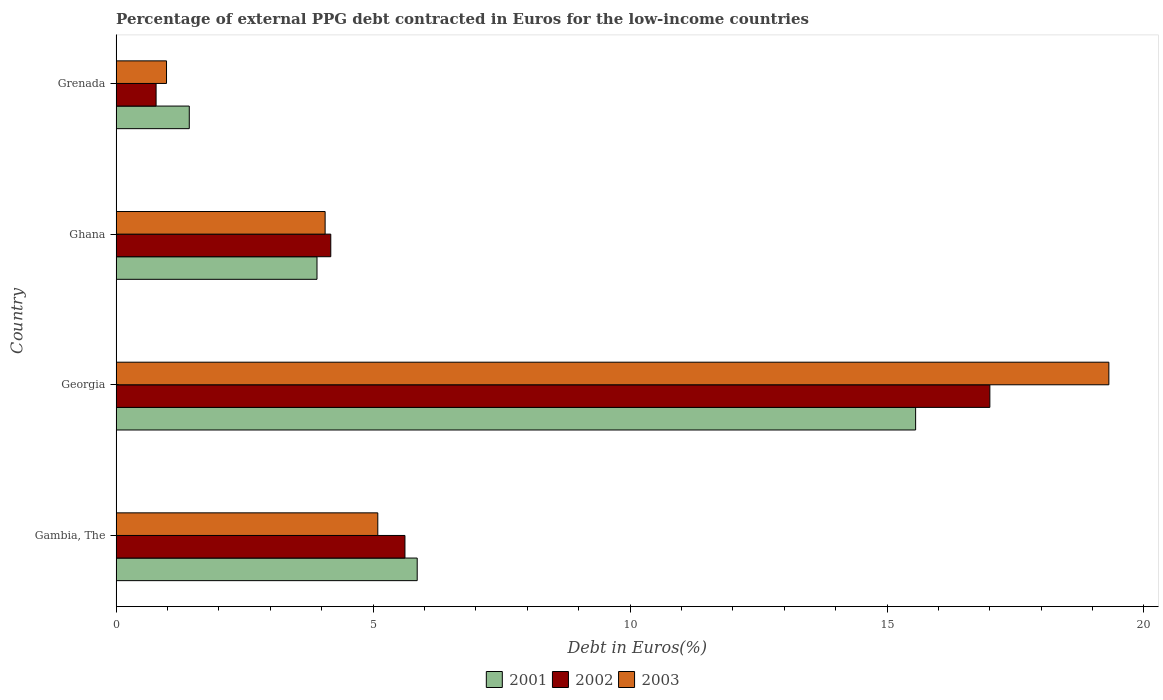How many different coloured bars are there?
Provide a short and direct response. 3. What is the percentage of external PPG debt contracted in Euros in 2001 in Georgia?
Ensure brevity in your answer.  15.56. Across all countries, what is the maximum percentage of external PPG debt contracted in Euros in 2001?
Make the answer very short. 15.56. Across all countries, what is the minimum percentage of external PPG debt contracted in Euros in 2002?
Your response must be concise. 0.78. In which country was the percentage of external PPG debt contracted in Euros in 2002 maximum?
Give a very brief answer. Georgia. In which country was the percentage of external PPG debt contracted in Euros in 2003 minimum?
Offer a terse response. Grenada. What is the total percentage of external PPG debt contracted in Euros in 2003 in the graph?
Your answer should be compact. 29.45. What is the difference between the percentage of external PPG debt contracted in Euros in 2003 in Georgia and that in Grenada?
Offer a terse response. 18.34. What is the difference between the percentage of external PPG debt contracted in Euros in 2003 in Gambia, The and the percentage of external PPG debt contracted in Euros in 2002 in Georgia?
Make the answer very short. -11.91. What is the average percentage of external PPG debt contracted in Euros in 2003 per country?
Your response must be concise. 7.36. What is the difference between the percentage of external PPG debt contracted in Euros in 2002 and percentage of external PPG debt contracted in Euros in 2001 in Gambia, The?
Your response must be concise. -0.24. What is the ratio of the percentage of external PPG debt contracted in Euros in 2002 in Georgia to that in Grenada?
Give a very brief answer. 21.87. What is the difference between the highest and the second highest percentage of external PPG debt contracted in Euros in 2002?
Ensure brevity in your answer.  11.38. What is the difference between the highest and the lowest percentage of external PPG debt contracted in Euros in 2001?
Provide a short and direct response. 14.13. In how many countries, is the percentage of external PPG debt contracted in Euros in 2001 greater than the average percentage of external PPG debt contracted in Euros in 2001 taken over all countries?
Give a very brief answer. 1. What does the 2nd bar from the bottom in Gambia, The represents?
Provide a short and direct response. 2002. How many bars are there?
Ensure brevity in your answer.  12. Are all the bars in the graph horizontal?
Your answer should be very brief. Yes. What is the difference between two consecutive major ticks on the X-axis?
Offer a very short reply. 5. Are the values on the major ticks of X-axis written in scientific E-notation?
Keep it short and to the point. No. Does the graph contain any zero values?
Offer a terse response. No. Does the graph contain grids?
Your response must be concise. No. Where does the legend appear in the graph?
Provide a succinct answer. Bottom center. How many legend labels are there?
Make the answer very short. 3. How are the legend labels stacked?
Ensure brevity in your answer.  Horizontal. What is the title of the graph?
Your answer should be very brief. Percentage of external PPG debt contracted in Euros for the low-income countries. What is the label or title of the X-axis?
Make the answer very short. Debt in Euros(%). What is the Debt in Euros(%) of 2001 in Gambia, The?
Keep it short and to the point. 5.86. What is the Debt in Euros(%) in 2002 in Gambia, The?
Give a very brief answer. 5.62. What is the Debt in Euros(%) in 2003 in Gambia, The?
Make the answer very short. 5.09. What is the Debt in Euros(%) in 2001 in Georgia?
Offer a very short reply. 15.56. What is the Debt in Euros(%) in 2002 in Georgia?
Offer a very short reply. 17. What is the Debt in Euros(%) in 2003 in Georgia?
Make the answer very short. 19.32. What is the Debt in Euros(%) in 2001 in Ghana?
Provide a short and direct response. 3.91. What is the Debt in Euros(%) in 2002 in Ghana?
Offer a terse response. 4.18. What is the Debt in Euros(%) in 2003 in Ghana?
Keep it short and to the point. 4.07. What is the Debt in Euros(%) in 2001 in Grenada?
Give a very brief answer. 1.42. What is the Debt in Euros(%) of 2002 in Grenada?
Your answer should be compact. 0.78. What is the Debt in Euros(%) of 2003 in Grenada?
Offer a very short reply. 0.98. Across all countries, what is the maximum Debt in Euros(%) in 2001?
Your answer should be compact. 15.56. Across all countries, what is the maximum Debt in Euros(%) in 2002?
Keep it short and to the point. 17. Across all countries, what is the maximum Debt in Euros(%) of 2003?
Offer a terse response. 19.32. Across all countries, what is the minimum Debt in Euros(%) in 2001?
Make the answer very short. 1.42. Across all countries, what is the minimum Debt in Euros(%) of 2002?
Your answer should be very brief. 0.78. Across all countries, what is the minimum Debt in Euros(%) of 2003?
Your answer should be very brief. 0.98. What is the total Debt in Euros(%) of 2001 in the graph?
Offer a terse response. 26.75. What is the total Debt in Euros(%) of 2002 in the graph?
Keep it short and to the point. 27.58. What is the total Debt in Euros(%) in 2003 in the graph?
Your response must be concise. 29.45. What is the difference between the Debt in Euros(%) of 2001 in Gambia, The and that in Georgia?
Make the answer very short. -9.7. What is the difference between the Debt in Euros(%) of 2002 in Gambia, The and that in Georgia?
Keep it short and to the point. -11.38. What is the difference between the Debt in Euros(%) in 2003 in Gambia, The and that in Georgia?
Your answer should be compact. -14.23. What is the difference between the Debt in Euros(%) in 2001 in Gambia, The and that in Ghana?
Offer a very short reply. 1.95. What is the difference between the Debt in Euros(%) of 2002 in Gambia, The and that in Ghana?
Provide a succinct answer. 1.44. What is the difference between the Debt in Euros(%) of 2003 in Gambia, The and that in Ghana?
Offer a very short reply. 1.02. What is the difference between the Debt in Euros(%) in 2001 in Gambia, The and that in Grenada?
Offer a terse response. 4.43. What is the difference between the Debt in Euros(%) in 2002 in Gambia, The and that in Grenada?
Your response must be concise. 4.84. What is the difference between the Debt in Euros(%) in 2003 in Gambia, The and that in Grenada?
Your response must be concise. 4.11. What is the difference between the Debt in Euros(%) in 2001 in Georgia and that in Ghana?
Keep it short and to the point. 11.65. What is the difference between the Debt in Euros(%) in 2002 in Georgia and that in Ghana?
Your response must be concise. 12.82. What is the difference between the Debt in Euros(%) in 2003 in Georgia and that in Ghana?
Provide a short and direct response. 15.25. What is the difference between the Debt in Euros(%) of 2001 in Georgia and that in Grenada?
Provide a short and direct response. 14.13. What is the difference between the Debt in Euros(%) in 2002 in Georgia and that in Grenada?
Your answer should be very brief. 16.22. What is the difference between the Debt in Euros(%) in 2003 in Georgia and that in Grenada?
Ensure brevity in your answer.  18.34. What is the difference between the Debt in Euros(%) of 2001 in Ghana and that in Grenada?
Make the answer very short. 2.48. What is the difference between the Debt in Euros(%) in 2002 in Ghana and that in Grenada?
Offer a very short reply. 3.4. What is the difference between the Debt in Euros(%) of 2003 in Ghana and that in Grenada?
Offer a terse response. 3.09. What is the difference between the Debt in Euros(%) of 2001 in Gambia, The and the Debt in Euros(%) of 2002 in Georgia?
Keep it short and to the point. -11.14. What is the difference between the Debt in Euros(%) of 2001 in Gambia, The and the Debt in Euros(%) of 2003 in Georgia?
Offer a very short reply. -13.46. What is the difference between the Debt in Euros(%) in 2002 in Gambia, The and the Debt in Euros(%) in 2003 in Georgia?
Give a very brief answer. -13.7. What is the difference between the Debt in Euros(%) of 2001 in Gambia, The and the Debt in Euros(%) of 2002 in Ghana?
Your answer should be compact. 1.68. What is the difference between the Debt in Euros(%) in 2001 in Gambia, The and the Debt in Euros(%) in 2003 in Ghana?
Your answer should be very brief. 1.79. What is the difference between the Debt in Euros(%) in 2002 in Gambia, The and the Debt in Euros(%) in 2003 in Ghana?
Offer a terse response. 1.55. What is the difference between the Debt in Euros(%) of 2001 in Gambia, The and the Debt in Euros(%) of 2002 in Grenada?
Make the answer very short. 5.08. What is the difference between the Debt in Euros(%) in 2001 in Gambia, The and the Debt in Euros(%) in 2003 in Grenada?
Offer a terse response. 4.88. What is the difference between the Debt in Euros(%) in 2002 in Gambia, The and the Debt in Euros(%) in 2003 in Grenada?
Keep it short and to the point. 4.64. What is the difference between the Debt in Euros(%) in 2001 in Georgia and the Debt in Euros(%) in 2002 in Ghana?
Make the answer very short. 11.38. What is the difference between the Debt in Euros(%) of 2001 in Georgia and the Debt in Euros(%) of 2003 in Ghana?
Offer a terse response. 11.49. What is the difference between the Debt in Euros(%) in 2002 in Georgia and the Debt in Euros(%) in 2003 in Ghana?
Ensure brevity in your answer.  12.93. What is the difference between the Debt in Euros(%) of 2001 in Georgia and the Debt in Euros(%) of 2002 in Grenada?
Make the answer very short. 14.78. What is the difference between the Debt in Euros(%) in 2001 in Georgia and the Debt in Euros(%) in 2003 in Grenada?
Offer a terse response. 14.58. What is the difference between the Debt in Euros(%) of 2002 in Georgia and the Debt in Euros(%) of 2003 in Grenada?
Offer a terse response. 16.02. What is the difference between the Debt in Euros(%) in 2001 in Ghana and the Debt in Euros(%) in 2002 in Grenada?
Keep it short and to the point. 3.13. What is the difference between the Debt in Euros(%) in 2001 in Ghana and the Debt in Euros(%) in 2003 in Grenada?
Ensure brevity in your answer.  2.93. What is the difference between the Debt in Euros(%) in 2002 in Ghana and the Debt in Euros(%) in 2003 in Grenada?
Your answer should be very brief. 3.2. What is the average Debt in Euros(%) of 2001 per country?
Provide a succinct answer. 6.69. What is the average Debt in Euros(%) of 2002 per country?
Your answer should be very brief. 6.89. What is the average Debt in Euros(%) of 2003 per country?
Your response must be concise. 7.36. What is the difference between the Debt in Euros(%) in 2001 and Debt in Euros(%) in 2002 in Gambia, The?
Provide a succinct answer. 0.24. What is the difference between the Debt in Euros(%) in 2001 and Debt in Euros(%) in 2003 in Gambia, The?
Your answer should be very brief. 0.77. What is the difference between the Debt in Euros(%) of 2002 and Debt in Euros(%) of 2003 in Gambia, The?
Offer a terse response. 0.53. What is the difference between the Debt in Euros(%) in 2001 and Debt in Euros(%) in 2002 in Georgia?
Offer a very short reply. -1.44. What is the difference between the Debt in Euros(%) of 2001 and Debt in Euros(%) of 2003 in Georgia?
Keep it short and to the point. -3.76. What is the difference between the Debt in Euros(%) of 2002 and Debt in Euros(%) of 2003 in Georgia?
Your answer should be compact. -2.32. What is the difference between the Debt in Euros(%) in 2001 and Debt in Euros(%) in 2002 in Ghana?
Keep it short and to the point. -0.27. What is the difference between the Debt in Euros(%) in 2001 and Debt in Euros(%) in 2003 in Ghana?
Keep it short and to the point. -0.16. What is the difference between the Debt in Euros(%) of 2002 and Debt in Euros(%) of 2003 in Ghana?
Make the answer very short. 0.11. What is the difference between the Debt in Euros(%) in 2001 and Debt in Euros(%) in 2002 in Grenada?
Make the answer very short. 0.65. What is the difference between the Debt in Euros(%) of 2001 and Debt in Euros(%) of 2003 in Grenada?
Offer a very short reply. 0.44. What is the difference between the Debt in Euros(%) in 2002 and Debt in Euros(%) in 2003 in Grenada?
Offer a terse response. -0.2. What is the ratio of the Debt in Euros(%) in 2001 in Gambia, The to that in Georgia?
Offer a terse response. 0.38. What is the ratio of the Debt in Euros(%) of 2002 in Gambia, The to that in Georgia?
Give a very brief answer. 0.33. What is the ratio of the Debt in Euros(%) in 2003 in Gambia, The to that in Georgia?
Your response must be concise. 0.26. What is the ratio of the Debt in Euros(%) of 2001 in Gambia, The to that in Ghana?
Your response must be concise. 1.5. What is the ratio of the Debt in Euros(%) of 2002 in Gambia, The to that in Ghana?
Offer a terse response. 1.35. What is the ratio of the Debt in Euros(%) in 2003 in Gambia, The to that in Ghana?
Provide a succinct answer. 1.25. What is the ratio of the Debt in Euros(%) in 2001 in Gambia, The to that in Grenada?
Your answer should be compact. 4.12. What is the ratio of the Debt in Euros(%) in 2002 in Gambia, The to that in Grenada?
Make the answer very short. 7.23. What is the ratio of the Debt in Euros(%) of 2003 in Gambia, The to that in Grenada?
Give a very brief answer. 5.19. What is the ratio of the Debt in Euros(%) in 2001 in Georgia to that in Ghana?
Give a very brief answer. 3.98. What is the ratio of the Debt in Euros(%) in 2002 in Georgia to that in Ghana?
Make the answer very short. 4.07. What is the ratio of the Debt in Euros(%) in 2003 in Georgia to that in Ghana?
Make the answer very short. 4.75. What is the ratio of the Debt in Euros(%) in 2001 in Georgia to that in Grenada?
Provide a succinct answer. 10.93. What is the ratio of the Debt in Euros(%) of 2002 in Georgia to that in Grenada?
Your response must be concise. 21.87. What is the ratio of the Debt in Euros(%) of 2003 in Georgia to that in Grenada?
Give a very brief answer. 19.7. What is the ratio of the Debt in Euros(%) of 2001 in Ghana to that in Grenada?
Make the answer very short. 2.75. What is the ratio of the Debt in Euros(%) in 2002 in Ghana to that in Grenada?
Offer a very short reply. 5.37. What is the ratio of the Debt in Euros(%) of 2003 in Ghana to that in Grenada?
Ensure brevity in your answer.  4.15. What is the difference between the highest and the second highest Debt in Euros(%) of 2001?
Your answer should be compact. 9.7. What is the difference between the highest and the second highest Debt in Euros(%) in 2002?
Your response must be concise. 11.38. What is the difference between the highest and the second highest Debt in Euros(%) of 2003?
Ensure brevity in your answer.  14.23. What is the difference between the highest and the lowest Debt in Euros(%) in 2001?
Make the answer very short. 14.13. What is the difference between the highest and the lowest Debt in Euros(%) in 2002?
Offer a terse response. 16.22. What is the difference between the highest and the lowest Debt in Euros(%) in 2003?
Your answer should be very brief. 18.34. 